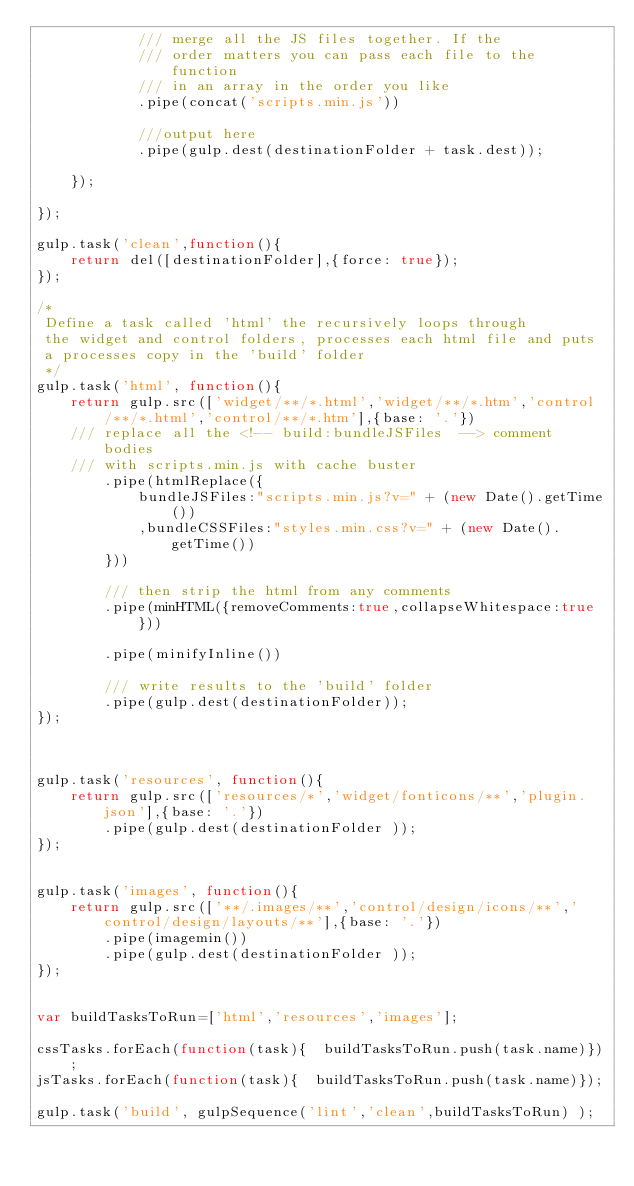Convert code to text. <code><loc_0><loc_0><loc_500><loc_500><_JavaScript_>            /// merge all the JS files together. If the
            /// order matters you can pass each file to the function
            /// in an array in the order you like
            .pipe(concat('scripts.min.js'))

            ///output here
            .pipe(gulp.dest(destinationFolder + task.dest));

    });

});

gulp.task('clean',function(){
    return del([destinationFolder],{force: true});
});

/*
 Define a task called 'html' the recursively loops through
 the widget and control folders, processes each html file and puts
 a processes copy in the 'build' folder
 */
gulp.task('html', function(){
    return gulp.src(['widget/**/*.html','widget/**/*.htm','control/**/*.html','control/**/*.htm'],{base: '.'})
    /// replace all the <!-- build:bundleJSFiles  --> comment bodies
    /// with scripts.min.js with cache buster
        .pipe(htmlReplace({
            bundleJSFiles:"scripts.min.js?v=" + (new Date().getTime())
            ,bundleCSSFiles:"styles.min.css?v=" + (new Date().getTime())
        }))

        /// then strip the html from any comments
        .pipe(minHTML({removeComments:true,collapseWhitespace:true}))

        .pipe(minifyInline())

        /// write results to the 'build' folder
        .pipe(gulp.dest(destinationFolder));
});



gulp.task('resources', function(){
    return gulp.src(['resources/*','widget/fonticons/**','plugin.json'],{base: '.'})
        .pipe(gulp.dest(destinationFolder ));
});


gulp.task('images', function(){
    return gulp.src(['**/.images/**','control/design/icons/**','control/design/layouts/**'],{base: '.'})
        .pipe(imagemin())
        .pipe(gulp.dest(destinationFolder ));
});


var buildTasksToRun=['html','resources','images'];

cssTasks.forEach(function(task){  buildTasksToRun.push(task.name)});
jsTasks.forEach(function(task){  buildTasksToRun.push(task.name)});

gulp.task('build', gulpSequence('lint','clean',buildTasksToRun) );
</code> 